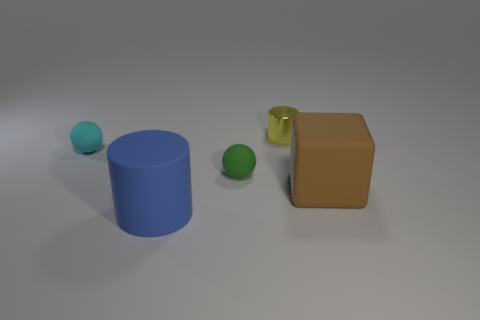Add 3 big objects. How many objects exist? 8 Subtract all spheres. How many objects are left? 3 Add 1 large cylinders. How many large cylinders are left? 2 Add 5 small purple rubber blocks. How many small purple rubber blocks exist? 5 Subtract 0 red cylinders. How many objects are left? 5 Subtract all big red metallic objects. Subtract all tiny rubber balls. How many objects are left? 3 